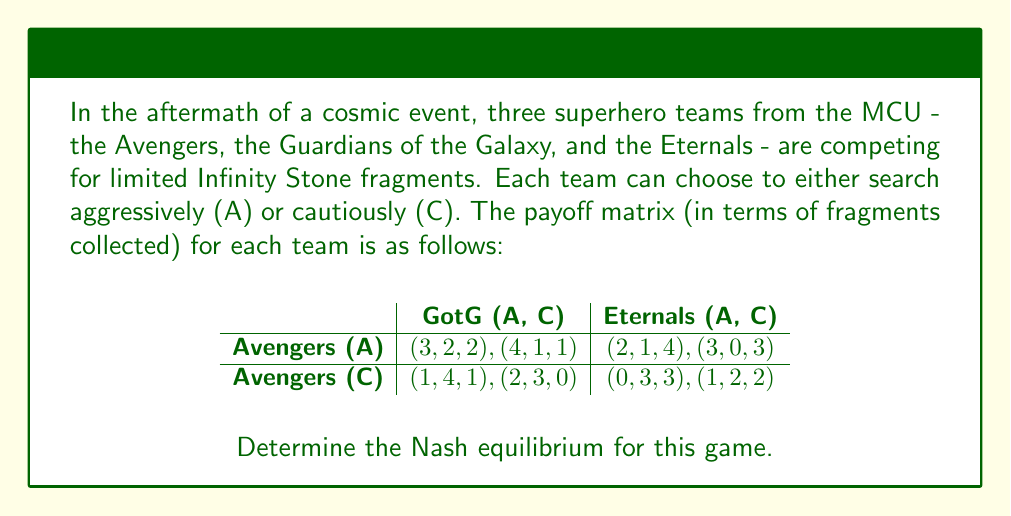Help me with this question. To find the Nash equilibrium, we need to analyze each team's best response to the other teams' strategies:

1) First, let's consider the Avengers' perspective:
   - If GotG and Eternals both choose A: Avengers get 3 (A) vs 1 (C)
   - If GotG chooses A and Eternals C: Avengers get 4 (A) vs 2 (C)
   - If GotG chooses C and Eternals A: Avengers get 2 (A) vs 0 (C)
   - If GotG and Eternals both choose C: Avengers get 3 (A) vs 1 (C)
   Avengers' best strategy is always A, regardless of what others choose.

2) Now, let's look at the Guardians of the Galaxy's perspective:
   - If Avengers choose A and Eternals A: GotG get 2 (A) vs 1 (C)
   - If Avengers choose A and Eternals C: GotG get 1 (A) vs 0 (C)
   - If Avengers choose C and Eternals A: GotG get 4 (A) vs 3 (C)
   - If Avengers choose C and Eternals C: GotG get 3 (A) vs 2 (C)
   GotG's best strategy is always A, regardless of what others choose.

3) Finally, let's consider the Eternals' perspective:
   - If Avengers choose A and GotG A: Eternals get 2 (A) vs 1 (C)
   - If Avengers choose A and GotG C: Eternals get 4 (A) vs 3 (C)
   - If Avengers choose C and GotG A: Eternals get 1 (A) vs 0 (C)
   - If Avengers choose C and GotG C: Eternals get 3 (A) vs 2 (C)
   Eternals' best strategy is always A, regardless of what others choose.

Since each team's best strategy is to choose A regardless of what the other teams do, the Nash equilibrium is (A, A, A), where all teams choose to search aggressively.
Answer: (A, A, A) 